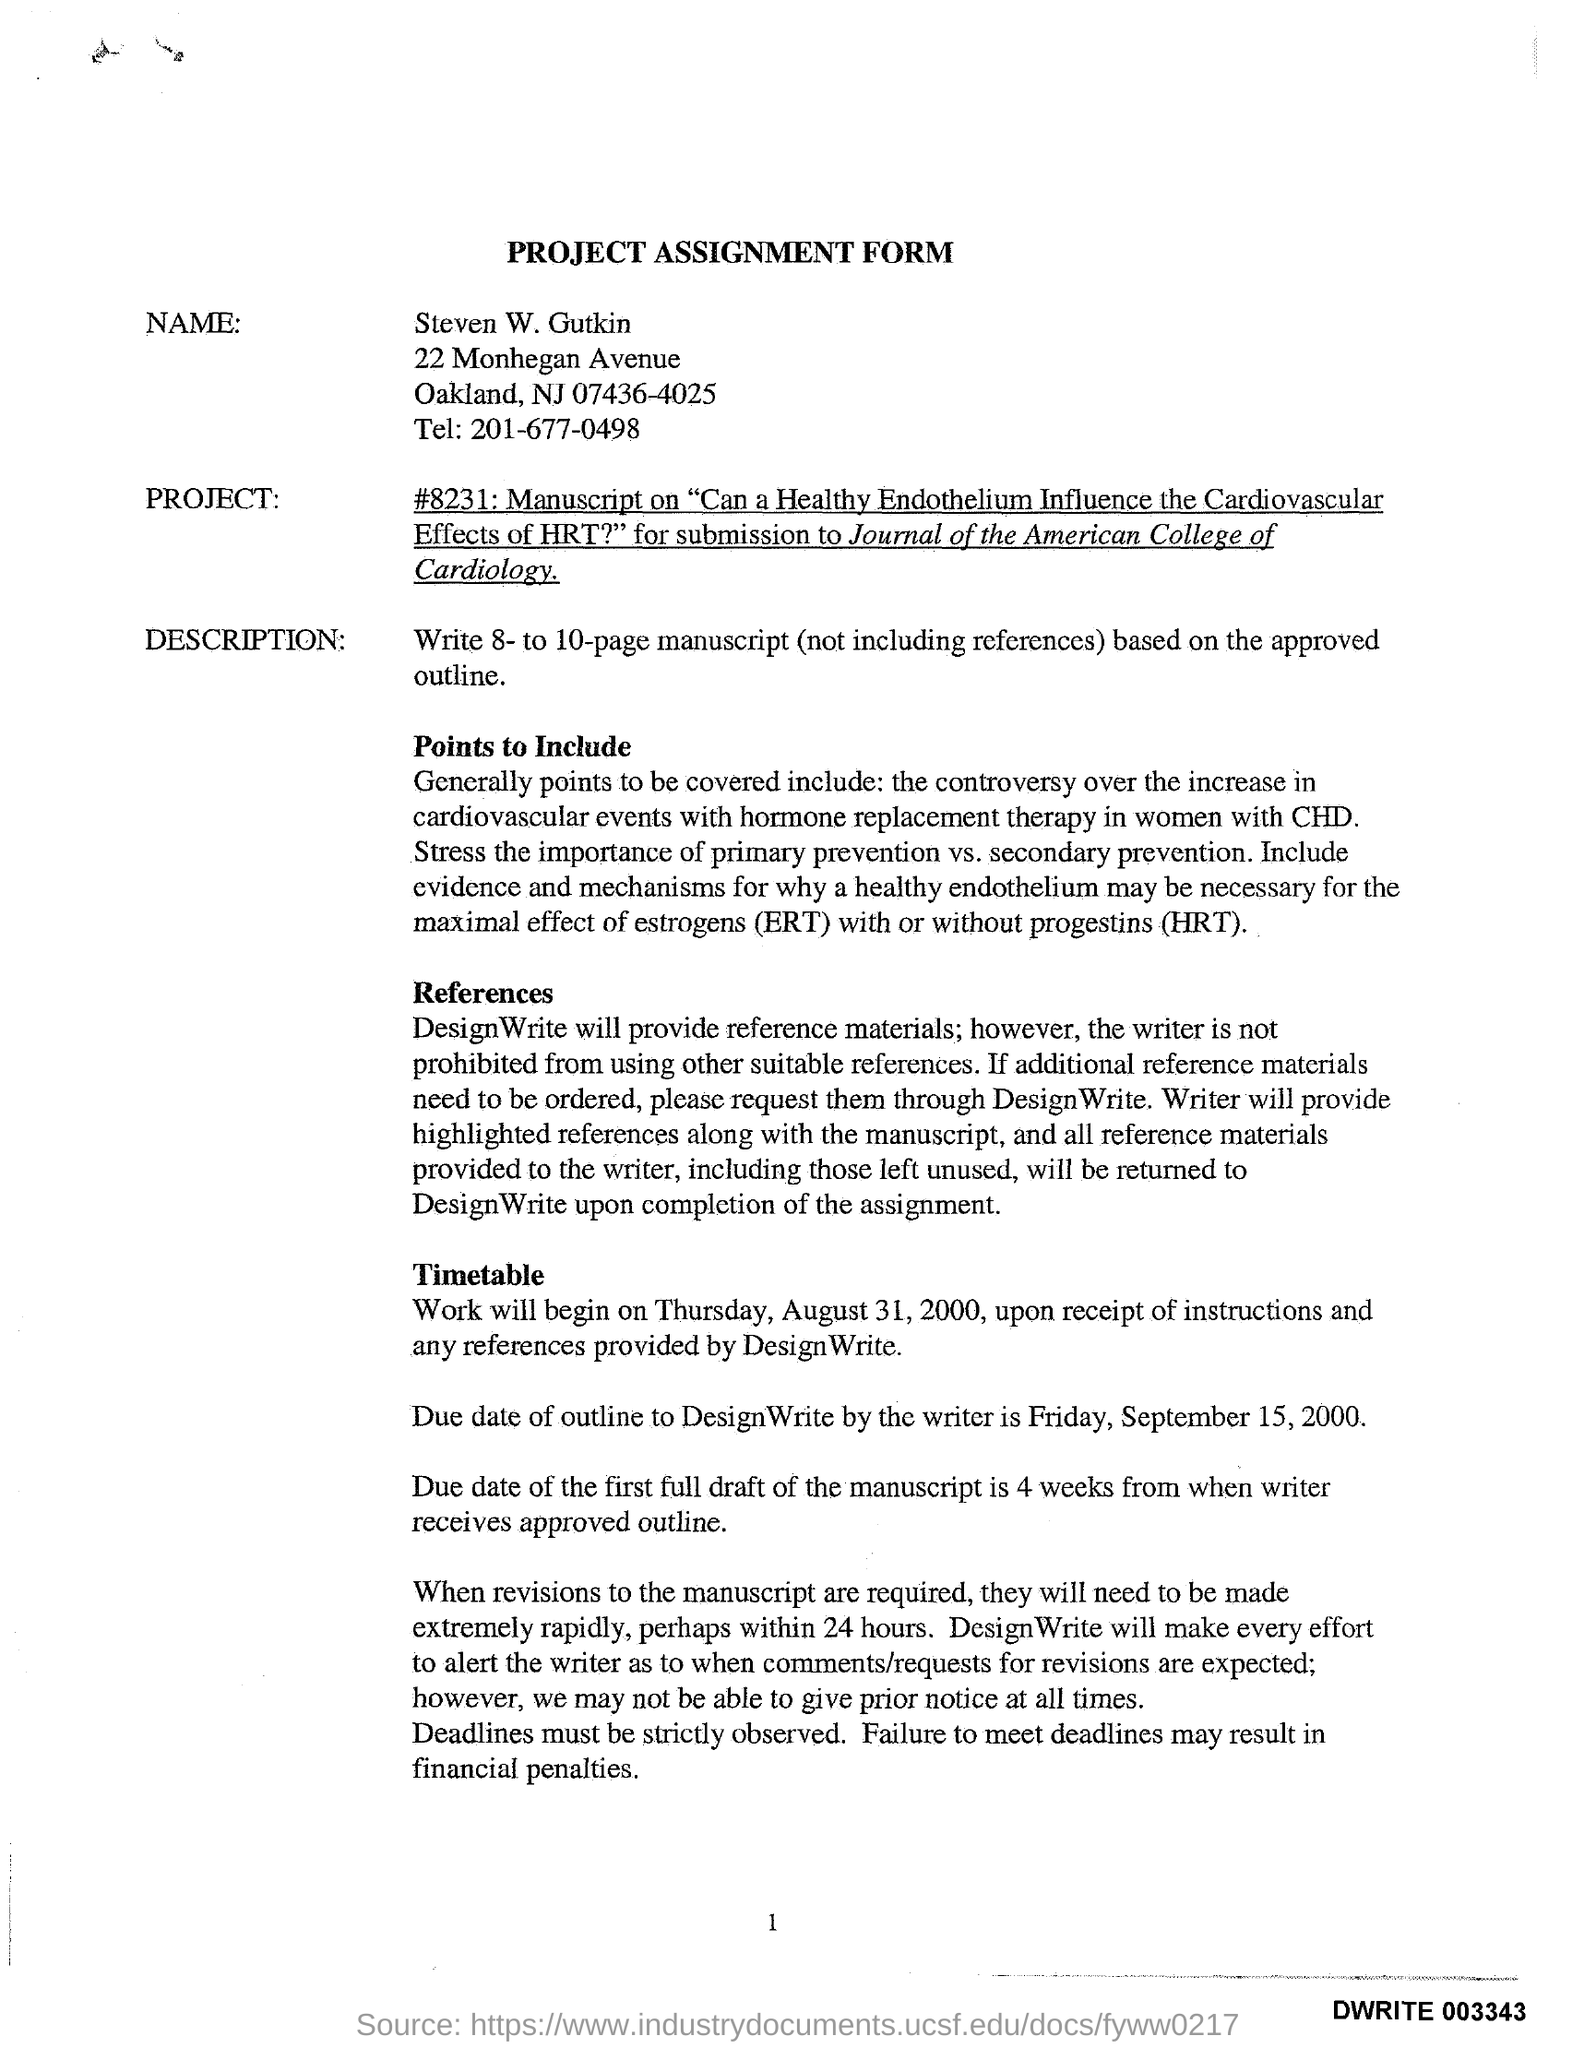What is the Title of the Form?
Ensure brevity in your answer.  Project Assignment Form. What is the Location for Steven W. Gutkin?
Ensure brevity in your answer.  Oakland. When will the work begin?
Offer a terse response. Thursday, August 31. 